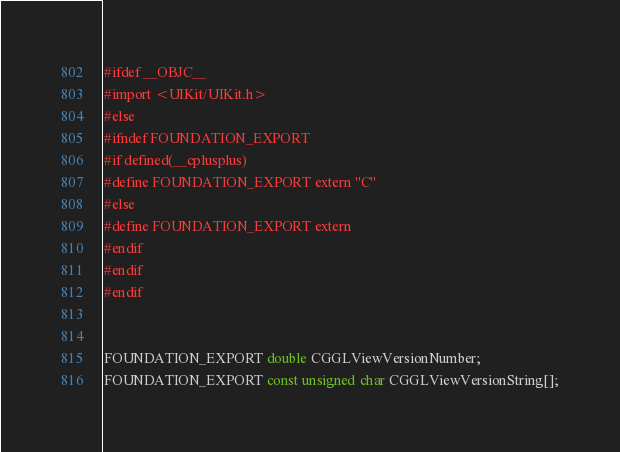<code> <loc_0><loc_0><loc_500><loc_500><_C_>#ifdef __OBJC__
#import <UIKit/UIKit.h>
#else
#ifndef FOUNDATION_EXPORT
#if defined(__cplusplus)
#define FOUNDATION_EXPORT extern "C"
#else
#define FOUNDATION_EXPORT extern
#endif
#endif
#endif


FOUNDATION_EXPORT double CGGLViewVersionNumber;
FOUNDATION_EXPORT const unsigned char CGGLViewVersionString[];

</code> 